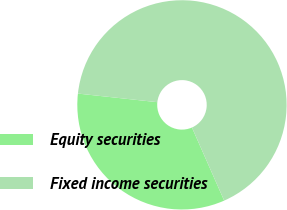<chart> <loc_0><loc_0><loc_500><loc_500><pie_chart><fcel>Equity securities<fcel>Fixed income securities<nl><fcel>33.33%<fcel>66.67%<nl></chart> 